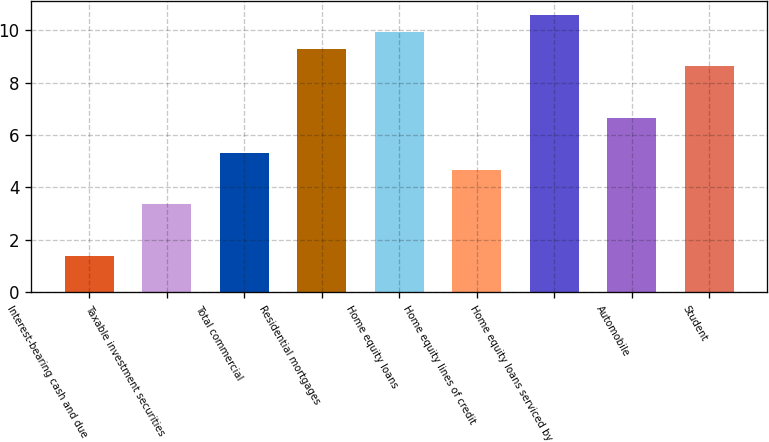<chart> <loc_0><loc_0><loc_500><loc_500><bar_chart><fcel>Interest-bearing cash and due<fcel>Taxable investment securities<fcel>Total commercial<fcel>Residential mortgages<fcel>Home equity loans<fcel>Home equity lines of credit<fcel>Home equity loans serviced by<fcel>Automobile<fcel>Student<nl><fcel>1.39<fcel>3.36<fcel>5.33<fcel>9.27<fcel>9.92<fcel>4.67<fcel>10.57<fcel>6.65<fcel>8.62<nl></chart> 